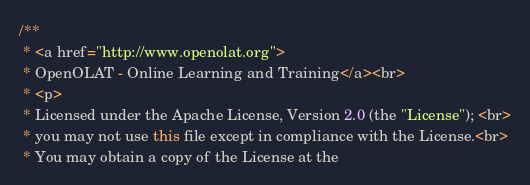Convert code to text. <code><loc_0><loc_0><loc_500><loc_500><_Java_>/**
 * <a href="http://www.openolat.org">
 * OpenOLAT - Online Learning and Training</a><br>
 * <p>
 * Licensed under the Apache License, Version 2.0 (the "License"); <br>
 * you may not use this file except in compliance with the License.<br>
 * You may obtain a copy of the License at the</code> 